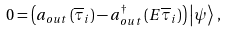<formula> <loc_0><loc_0><loc_500><loc_500>0 = \left ( a _ { o u t } \left ( \overline { \tau } _ { i } \right ) - a _ { o u t } ^ { \dagger } \left ( E \overline { \tau } _ { i } \right ) \right ) \left | \psi \right > \, ,</formula> 